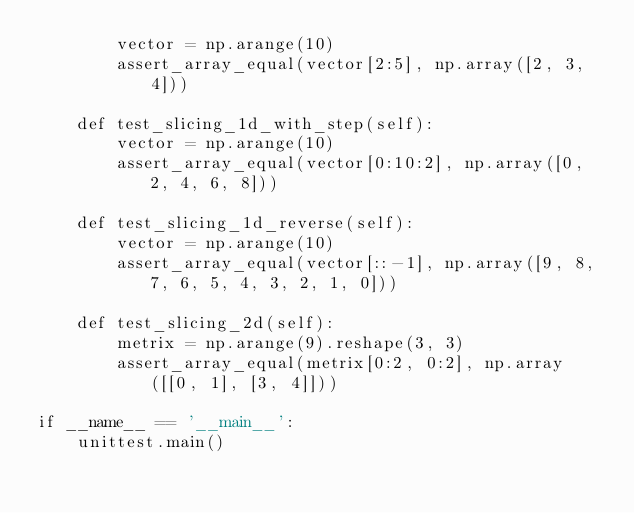Convert code to text. <code><loc_0><loc_0><loc_500><loc_500><_Python_>        vector = np.arange(10)
        assert_array_equal(vector[2:5], np.array([2, 3, 4]))

    def test_slicing_1d_with_step(self):
        vector = np.arange(10)
        assert_array_equal(vector[0:10:2], np.array([0, 2, 4, 6, 8]))

    def test_slicing_1d_reverse(self):
        vector = np.arange(10)
        assert_array_equal(vector[::-1], np.array([9, 8, 7, 6, 5, 4, 3, 2, 1, 0]))

    def test_slicing_2d(self):
        metrix = np.arange(9).reshape(3, 3)
        assert_array_equal(metrix[0:2, 0:2], np.array([[0, 1], [3, 4]]))

if __name__ == '__main__':
    unittest.main()</code> 